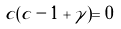Convert formula to latex. <formula><loc_0><loc_0><loc_500><loc_500>c ( c - 1 + \gamma ) = 0</formula> 